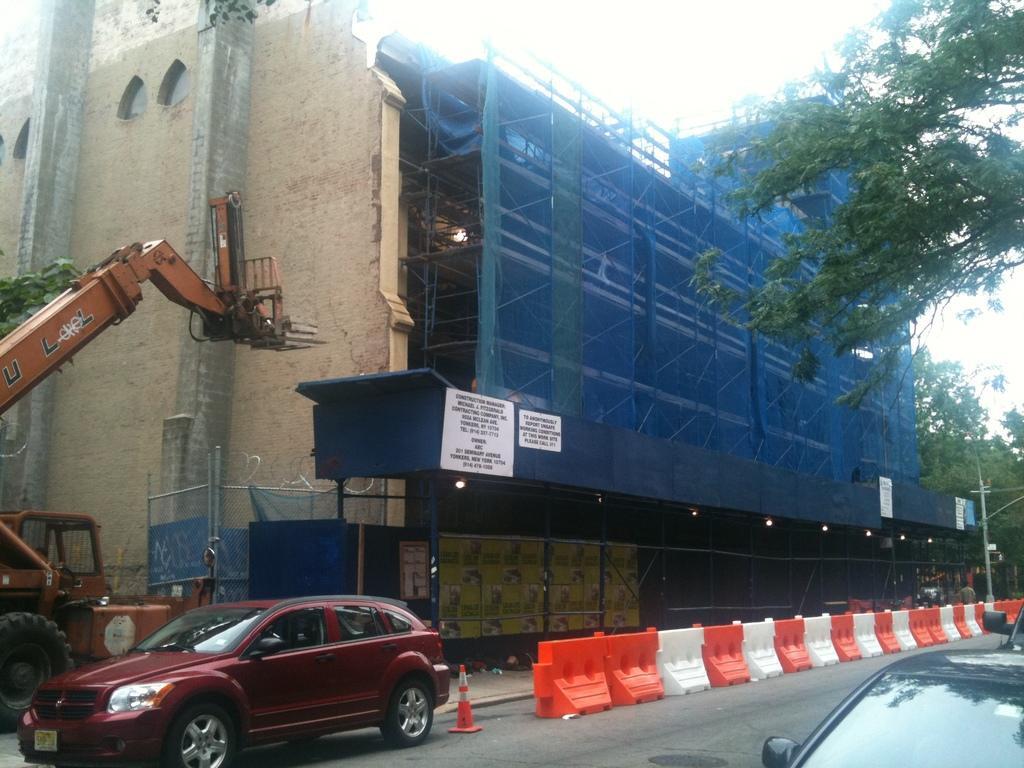Please provide a concise description of this image. In this image, we can see a building with walls, pillars and rods. At the bottom, we can see few vehicles, traffic cone, pole, road. Right side of the image, we can see few trees. 